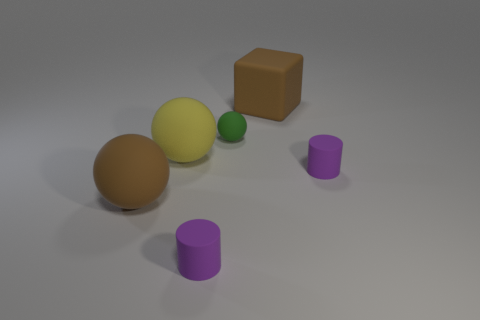There is a matte thing that is the same color as the large matte block; what is its size?
Offer a terse response. Large. Is there a big blue sphere?
Your answer should be very brief. No. There is a brown matte thing on the right side of the big brown ball; what size is it?
Offer a terse response. Large. What number of balls have the same color as the large block?
Give a very brief answer. 1. How many balls are purple rubber objects or tiny green matte objects?
Offer a terse response. 1. What is the shape of the thing that is on the right side of the large yellow matte thing and to the left of the tiny rubber sphere?
Offer a very short reply. Cylinder. Is there a purple object of the same size as the green sphere?
Provide a short and direct response. Yes. How many things are either brown rubber things behind the yellow ball or purple cylinders?
Provide a succinct answer. 3. How many things are either tiny purple matte things that are in front of the brown rubber sphere or large balls left of the large yellow rubber object?
Ensure brevity in your answer.  2. What number of other objects are the same color as the block?
Your answer should be compact. 1. 